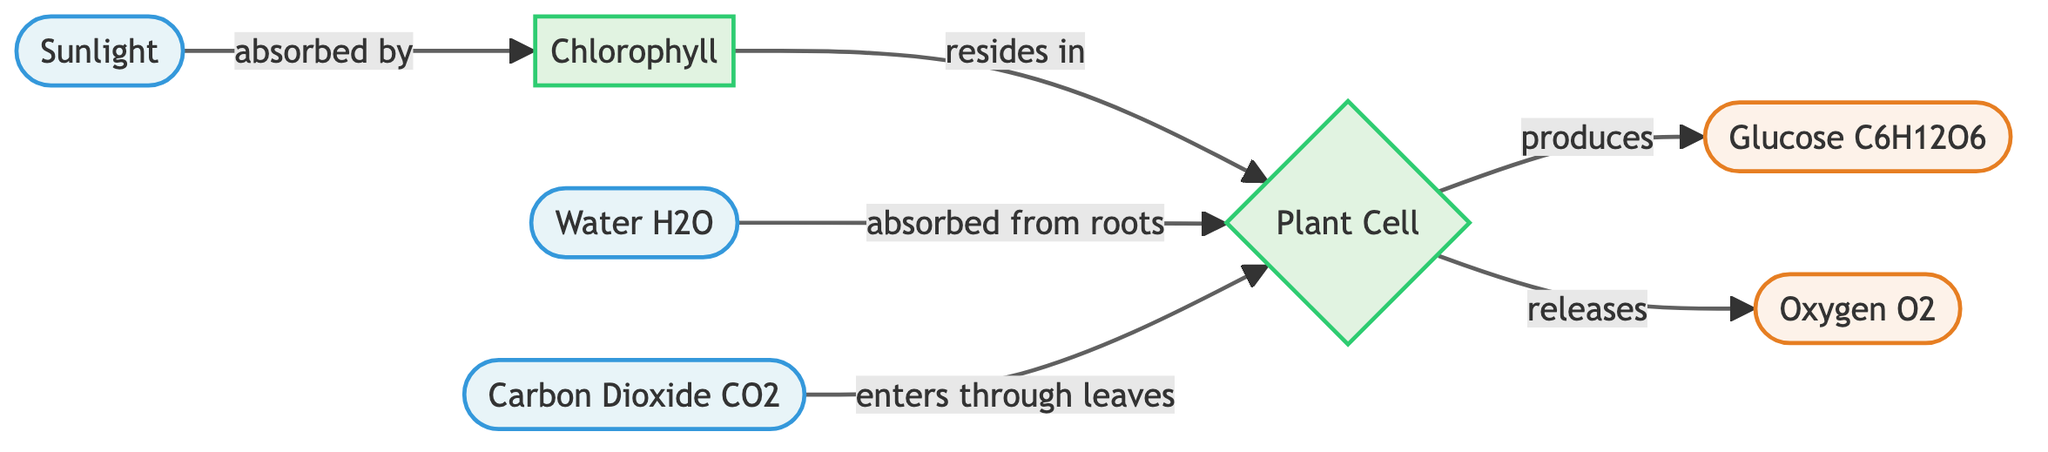What is the input for the photosynthesis process? The inputs for the photosynthesis process as depicted in the diagram are sunlight, water, and carbon dioxide. Each of these inputs is distinctly shown in the diagram as separate nodes leading to the plant cell.
Answer: sunlight, water, carbon dioxide What are the outputs of the photosynthesis process? The diagram specifies two outputs from the photosynthesis process, which are glucose and oxygen. These outputs are produced by the plant cell after processing the inputs.
Answer: glucose, oxygen How many inputs are shown in the diagram? The diagram presents three distinct input nodes: sunlight, water, and carbon dioxide. To determine the number of inputs, we count these nodes visually.
Answer: 3 What role does chlorophyll play in this process? Chlorophyll's role is indicated in the diagram as being absorbed by sunlight and residing in the plant cell, which is essential for the conversion of sunlight energy into chemical energy for photosynthesis.
Answer: absorbed by sunlight Which gas enters through the leaves of the plant? According to the diagram, carbon dioxide enters the plant cell through the leaves, specifically indicated by the directional arrow showing its entry point in the process.
Answer: carbon dioxide What does the plant cell produce as a result of photosynthesis? The plant cell produces glucose and releases oxygen as part of the photosynthesis process. These outputs are clearly indicated in the diagram as resultant products from the plant cell.
Answer: glucose, oxygen What is the relationship between water and the plant cell? The diagram illustrates that water is absorbed from the roots into the plant cell, indicating a critical relationship where water is utilized in the process of photosynthesis.
Answer: absorbed from roots How does sunlight contribute to photosynthesis? Sunlight contributes by being absorbed by chlorophyll, which is crucial for the plant's ability to carry out photosynthesis, as shown in the diagram's flow.
Answer: absorbed by chlorophyll What are the two main products of photosynthesis that benefit air quality? The two main products that benefit air quality are glucose and oxygen, both of which are released into the environment as a result of photosynthesis, as depicted in the outputs of the diagram.
Answer: glucose, oxygen 